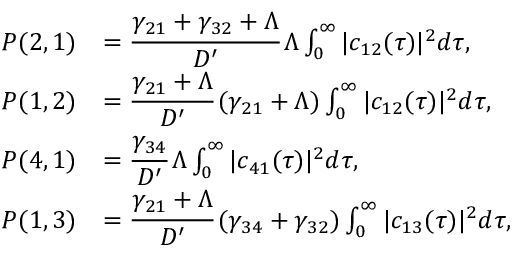<formula> <loc_0><loc_0><loc_500><loc_500>\begin{array} { r l } { P ( 2 , 1 ) } & { = \cfrac { \gamma _ { 2 1 } + \gamma _ { 3 2 } + \Lambda } { D ^ { \prime } } \, \Lambda \int _ { 0 } ^ { \infty } | c _ { 1 2 } ( \tau ) | ^ { 2 } d \tau , } \\ { P ( 1 , 2 ) } & { = \cfrac { \gamma _ { 2 1 } + \Lambda } { D ^ { \prime } } \, ( \gamma _ { 2 1 } + \Lambda ) \int _ { 0 } ^ { \infty } | c _ { 1 2 } ( \tau ) | ^ { 2 } d \tau , } \\ { P ( 4 , 1 ) } & { = \cfrac { \gamma _ { 3 4 } } { D ^ { \prime } } \, \Lambda \int _ { 0 } ^ { \infty } | c _ { 4 1 } ( \tau ) | ^ { 2 } d \tau , } \\ { P ( 1 , 3 ) } & { = \cfrac { \gamma _ { 2 1 } + \Lambda } { D ^ { \prime } } \, ( \gamma _ { 3 4 } + \gamma _ { 3 2 } ) \int _ { 0 } ^ { \infty } | c _ { 1 3 } ( \tau ) | ^ { 2 } d \tau , } \end{array}</formula> 